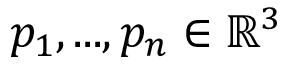<formula> <loc_0><loc_0><loc_500><loc_500>p _ { 1 } , \dots , p _ { n } \in \mathbb { R } ^ { 3 }</formula> 